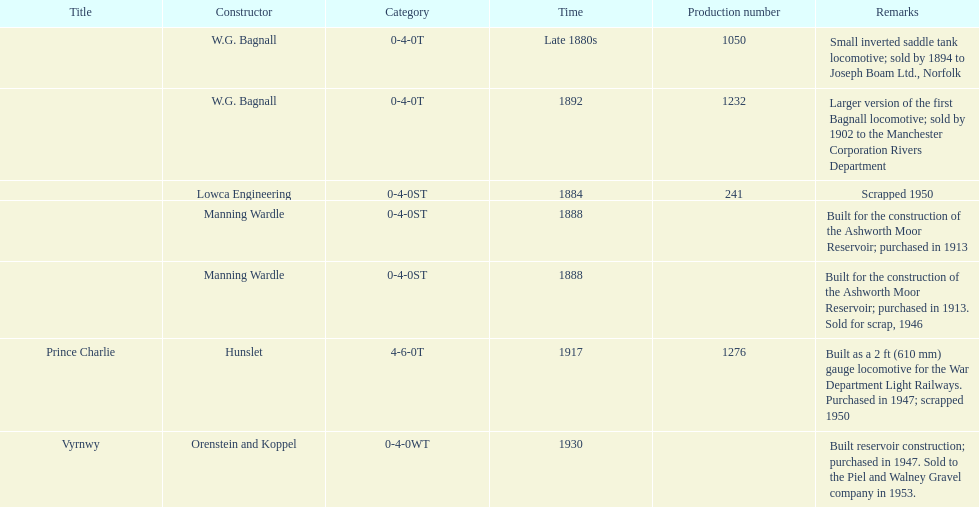How many locomotives were scrapped? 3. 